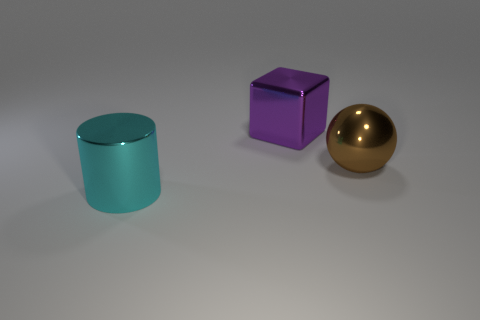How many big cylinders are there?
Provide a succinct answer. 1. What color is the big thing to the left of the metal thing that is behind the thing on the right side of the purple metallic object?
Your response must be concise. Cyan. Are there fewer objects than large metal balls?
Keep it short and to the point. No. There is a sphere that is the same material as the cyan cylinder; what color is it?
Your answer should be compact. Brown. What number of brown metal objects are the same size as the purple shiny cube?
Offer a very short reply. 1. What is the material of the big cyan thing?
Ensure brevity in your answer.  Metal. Are there more tiny yellow metal blocks than cylinders?
Keep it short and to the point. No. Is the shape of the large purple metallic thing the same as the big brown metallic thing?
Your answer should be compact. No. Is there any other thing that is the same shape as the big cyan object?
Offer a terse response. No. There is a large thing on the right side of the purple cube; is its color the same as the metallic object that is to the left of the purple metal cube?
Give a very brief answer. No. 